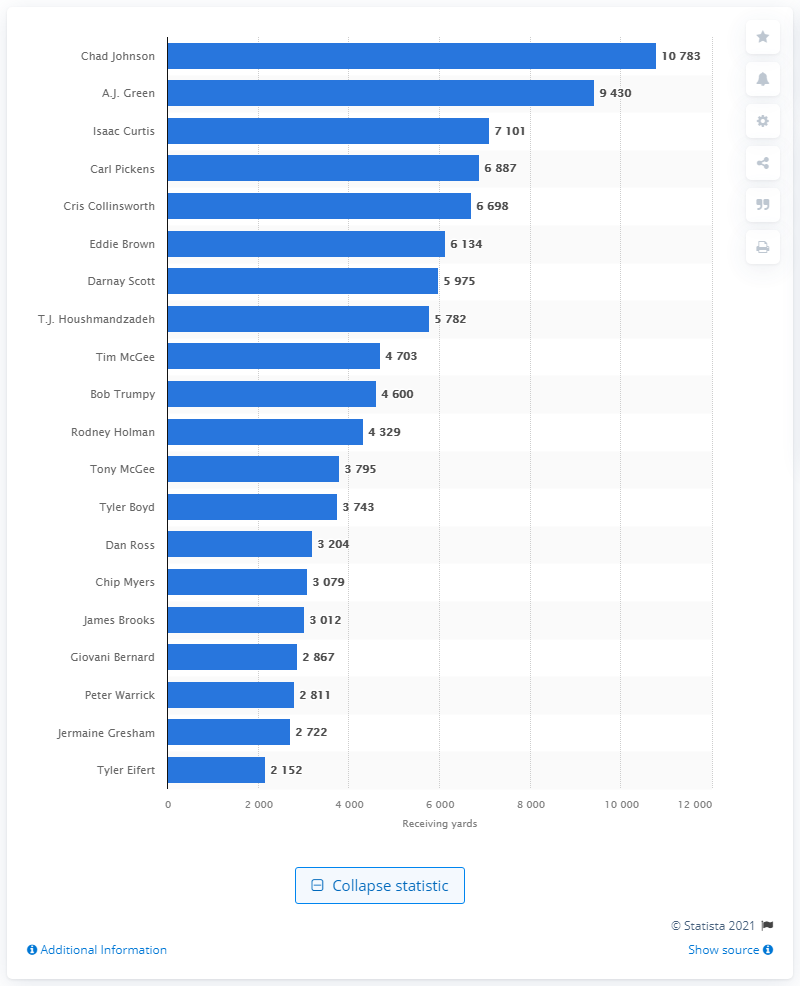Point out several critical features in this image. The career receiving leader of the Cincinnati Bengals is Chad Johnson. 